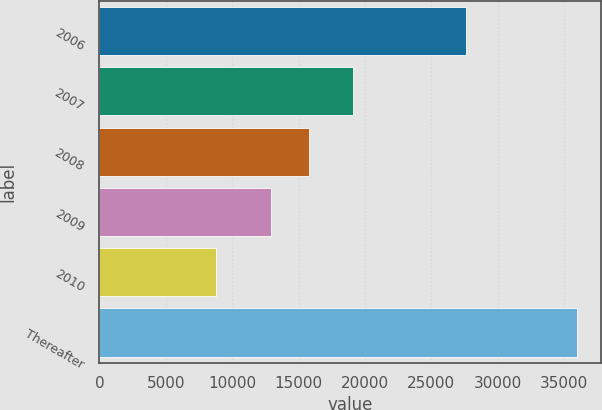<chart> <loc_0><loc_0><loc_500><loc_500><bar_chart><fcel>2006<fcel>2007<fcel>2008<fcel>2009<fcel>2010<fcel>Thereafter<nl><fcel>27589<fcel>19133<fcel>15795<fcel>12935<fcel>8802<fcel>35976<nl></chart> 